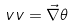<formula> <loc_0><loc_0><loc_500><loc_500>\ v v = \vec { \nabla } \theta</formula> 